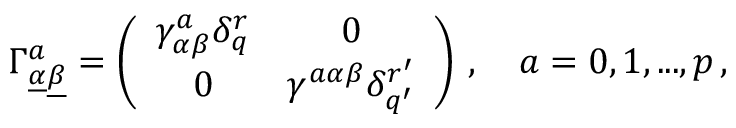<formula> <loc_0><loc_0><loc_500><loc_500>\Gamma _ { \underline { \alpha } \underline { \beta } } ^ { a } = \left ( \begin{array} { c c } { { \gamma _ { \alpha \beta } ^ { a } \delta _ { q } ^ { r } } } & { 0 } \\ { 0 } & { { \gamma ^ { a \alpha \beta } \delta _ { q ^ { \prime } } ^ { r ^ { \prime } } } } \end{array} \right ) \, , \quad a = 0 , 1 , \dots , p \, ,</formula> 